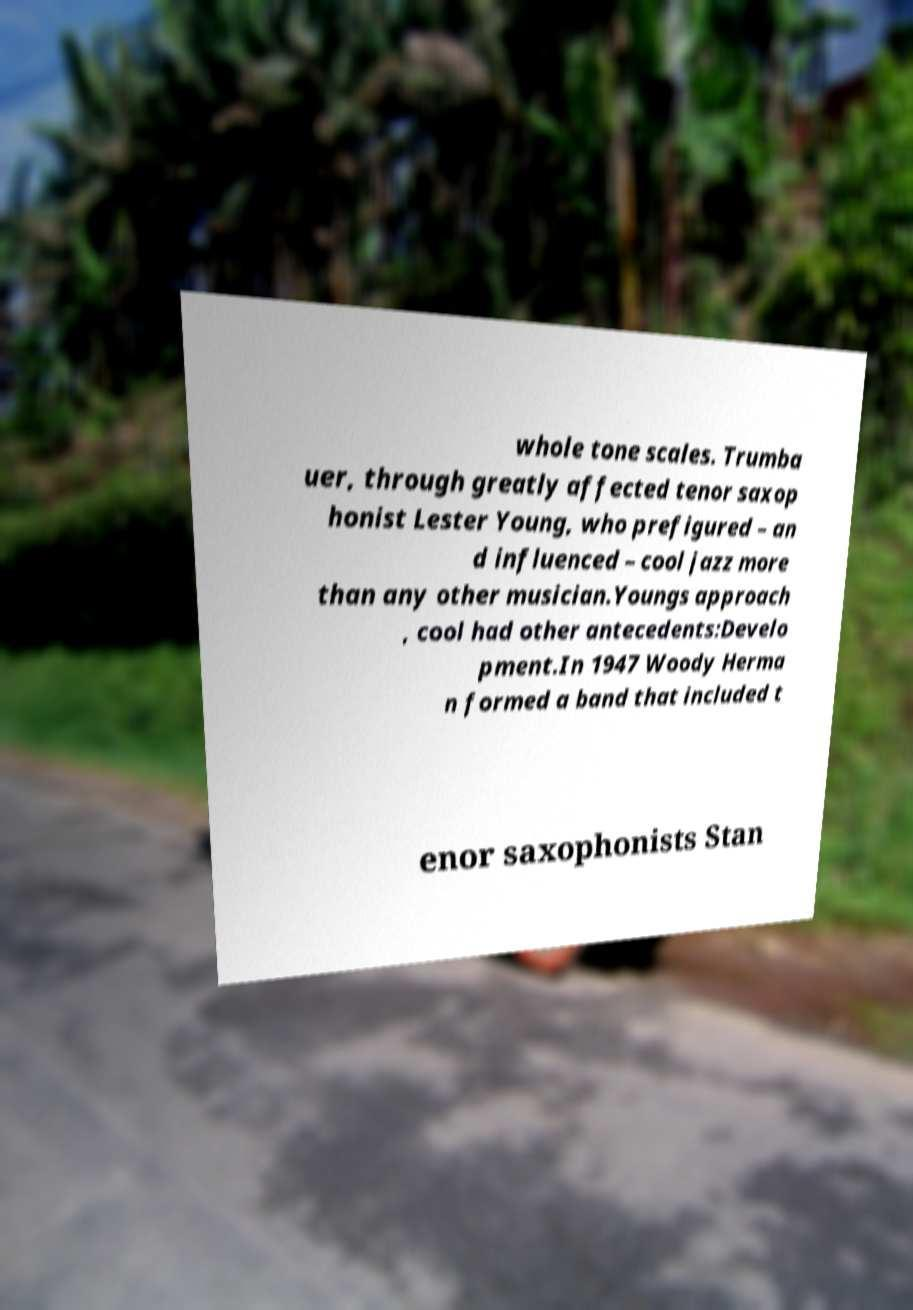I need the written content from this picture converted into text. Can you do that? whole tone scales. Trumba uer, through greatly affected tenor saxop honist Lester Young, who prefigured – an d influenced – cool jazz more than any other musician.Youngs approach , cool had other antecedents:Develo pment.In 1947 Woody Herma n formed a band that included t enor saxophonists Stan 